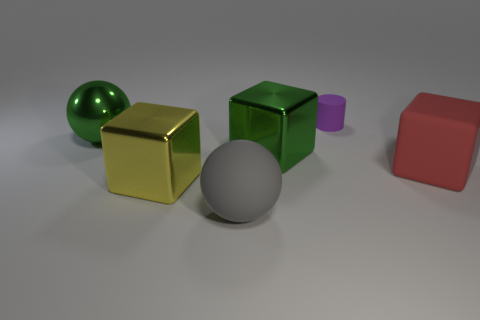Add 2 purple things. How many objects exist? 8 Subtract all spheres. How many objects are left? 4 Subtract all cyan metal cylinders. Subtract all purple matte objects. How many objects are left? 5 Add 5 large green shiny things. How many large green shiny things are left? 7 Add 6 big spheres. How many big spheres exist? 8 Subtract 0 gray cylinders. How many objects are left? 6 